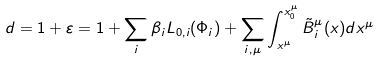<formula> <loc_0><loc_0><loc_500><loc_500>d = 1 + \varepsilon = 1 + \sum _ { i } { \beta _ { i } L _ { 0 , i } ( \Phi _ { i } ) } + \sum _ { i , \mu } { \int _ { x ^ { \mu } } ^ { x _ { 0 } ^ { \mu } } { \tilde { B } _ { i } ^ { \mu } ( x ) d x ^ { \mu } } }</formula> 